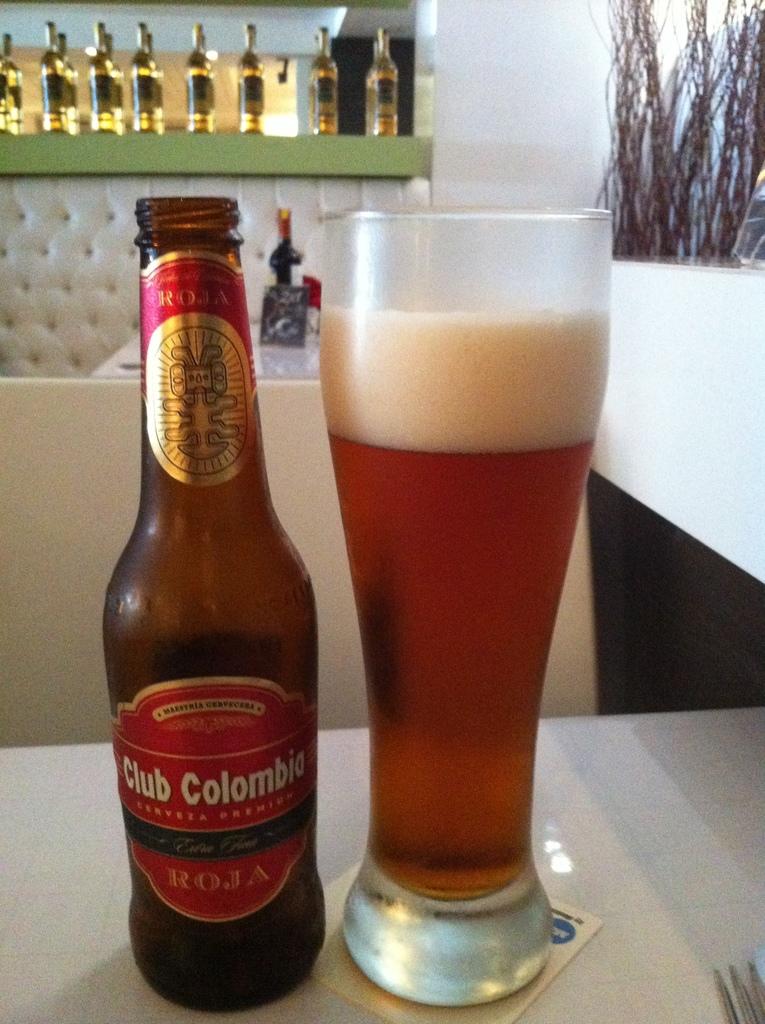What is the name of this beer?
Give a very brief answer. Club colombia. What brand of alcohol?
Keep it short and to the point. Club colombia. 